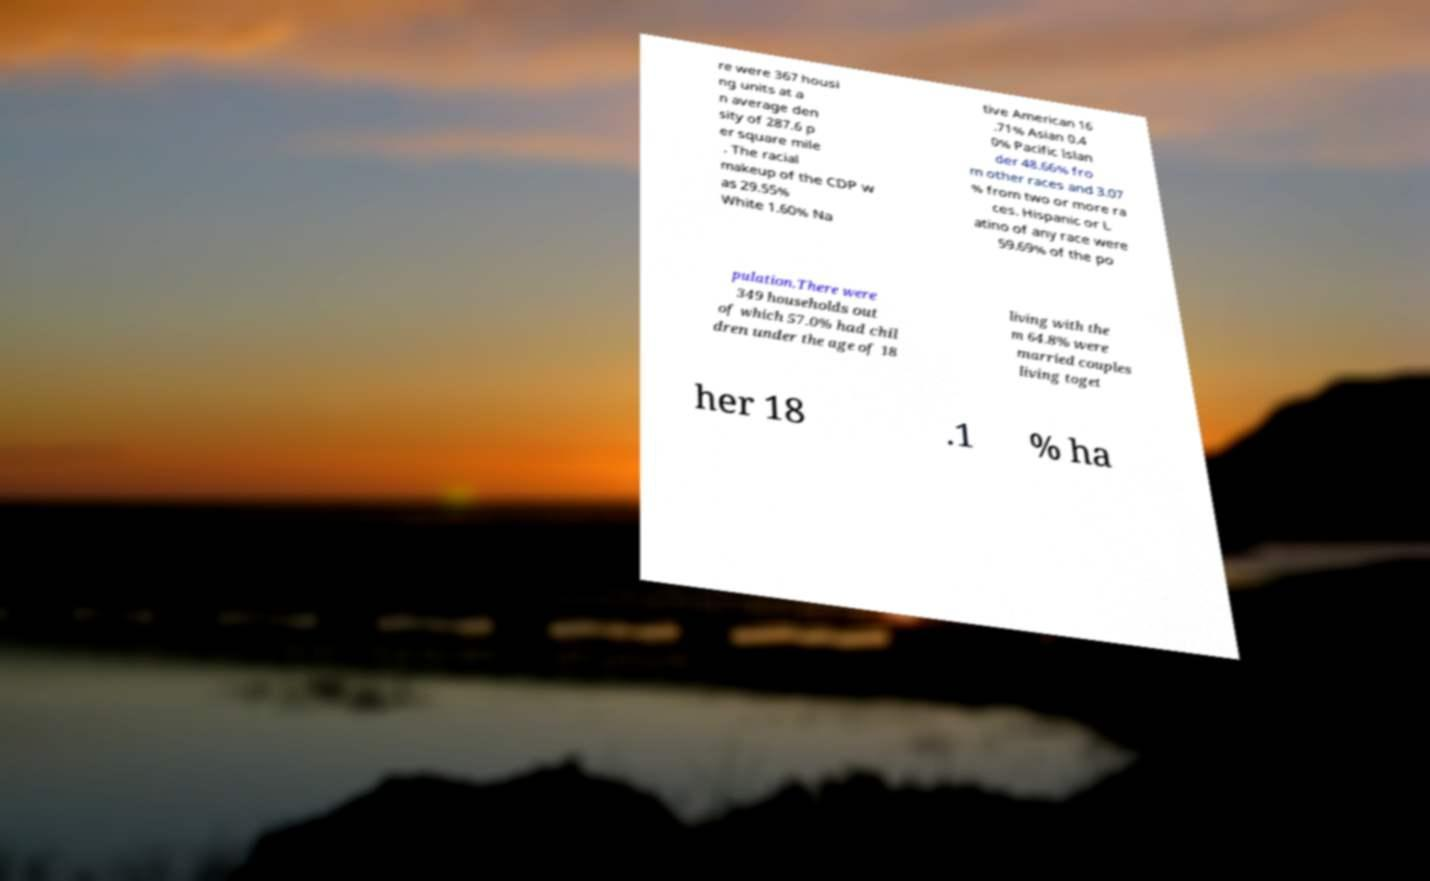Please identify and transcribe the text found in this image. re were 367 housi ng units at a n average den sity of 287.6 p er square mile . The racial makeup of the CDP w as 29.55% White 1.60% Na tive American 16 .71% Asian 0.4 0% Pacific Islan der 48.66% fro m other races and 3.07 % from two or more ra ces. Hispanic or L atino of any race were 59.69% of the po pulation.There were 349 households out of which 57.0% had chil dren under the age of 18 living with the m 64.8% were married couples living toget her 18 .1 % ha 